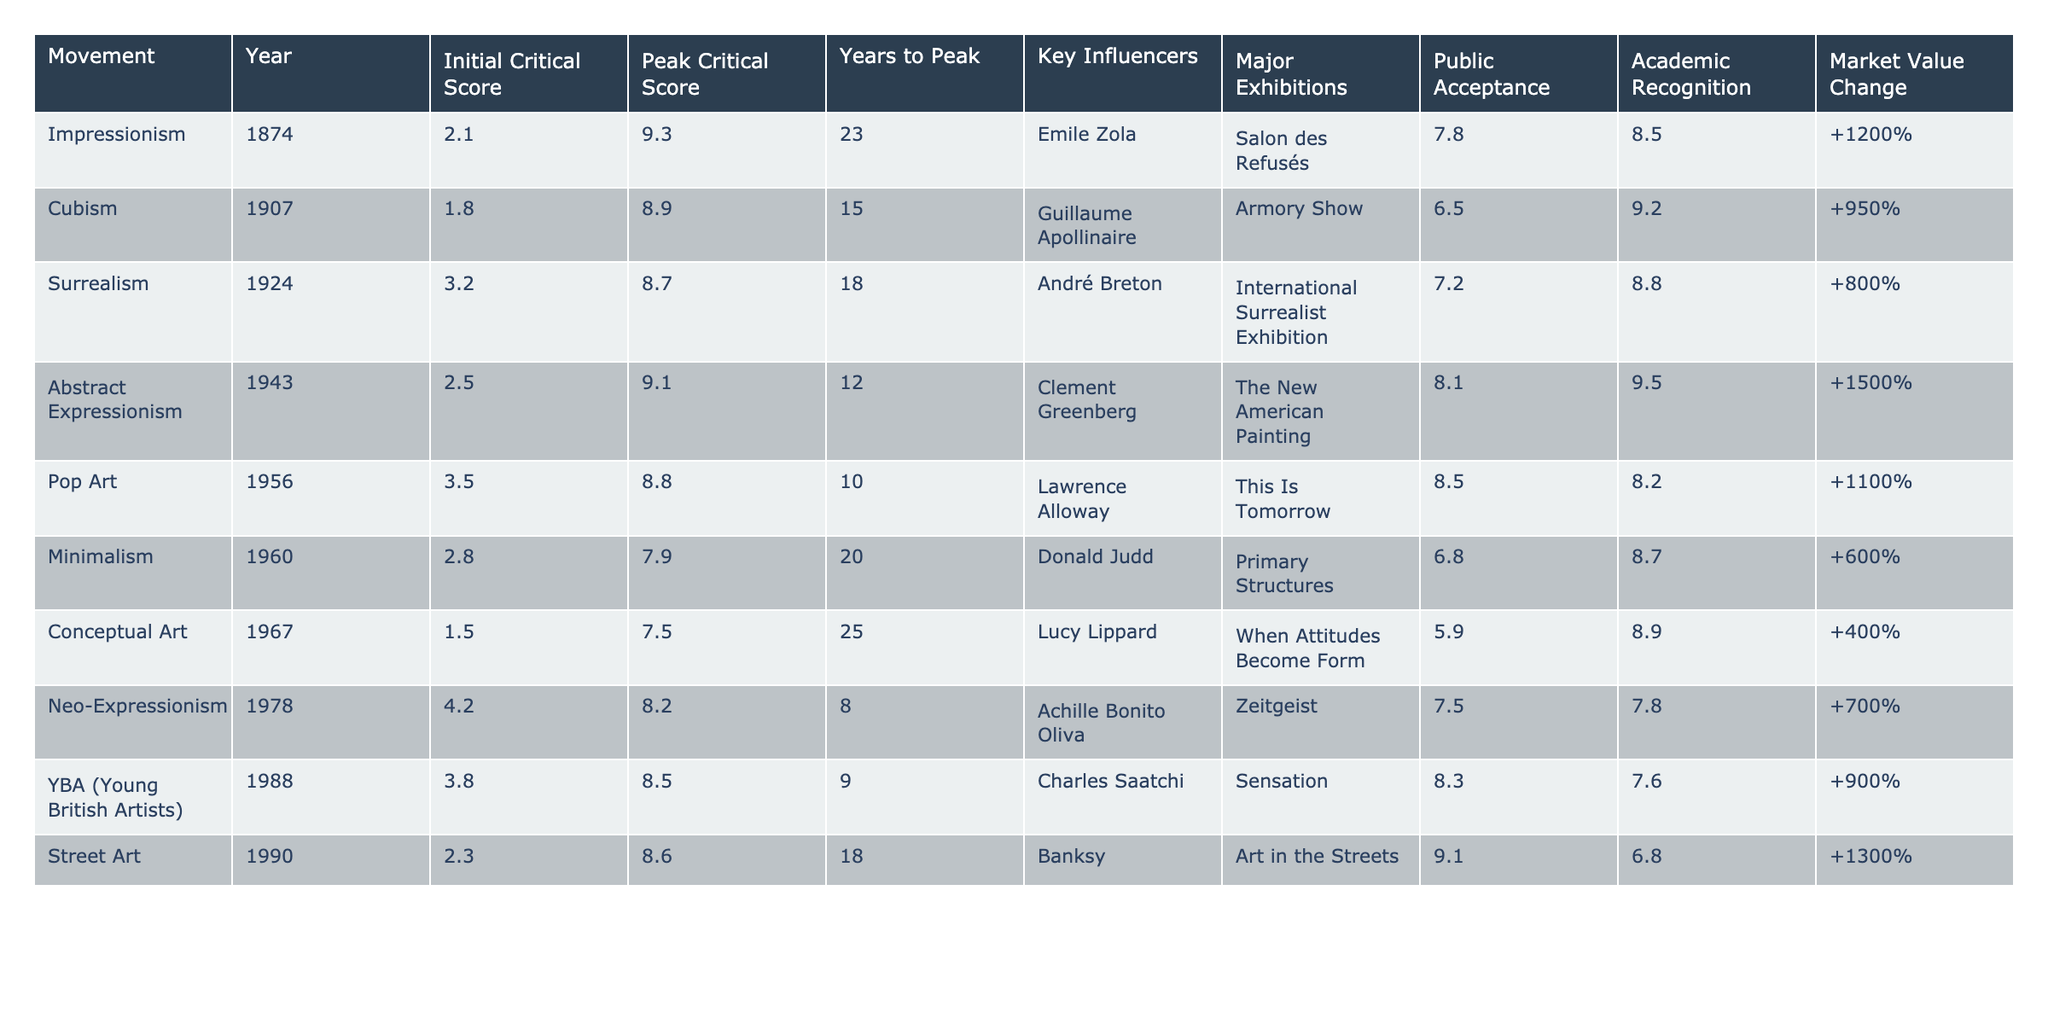What was the peak critical score for Abstract Expressionism? According to the table, the peak critical score for Abstract Expressionism is listed as 9.1.
Answer: 9.1 Which art movement had the highest initial critical score? By examining the initial critical scores in the table, Abstract Expressionism has the highest initial score of 2.5 compared to other movements.
Answer: Abstract Expressionism How many years did it take for Cubism to reach its peak critical score? The table shows that Cubism took 15 years to reach its peak critical score, as indicated under the "Years to Peak" column.
Answer: 15 years Is it true that Minimalism had a higher peak critical score than Surrealism? The peak critical score for Minimalism is 7.9, while Surrealism's peak score is 8.7, making the statement false.
Answer: No What is the difference in public acceptance between Pop Art and Street Art? The public acceptance for Pop Art is 8.5 and for Street Art is 9.1. The difference is calculated as 9.1 - 8.5 = 0.6.
Answer: 0.6 For which movement was the major exhibition 'Sensation' held? Looking at the table, the major exhibition 'Sensation' is associated with YBA (Young British Artists) in 1988.
Answer: YBA (Young British Artists) What is the average market value change for the first three movements listed? The market value changes for the first three movements (Impressionism, Cubism, and Surrealism) are +1200%, +950%, and +800%, respectively. Summing these values: 1200 + 950 + 800 = 2950, and dividing by 3 gives an average of 2950/3 = 983.33.
Answer: 983.33% Which movement had the lowest public acceptance score? By scanning the table, Conceptual Art has the lowest public acceptance score of 5.9 among the movements listed.
Answer: Conceptual Art If you list the movements in order of peak critical score, which one is in fifth place? The peak critical scores in descending order place Surrealism (8.7) fifth after Abstract Expressionism (9.1), Pop Art (8.8), and Cubism (8.9).
Answer: Surrealism How does the average years to peak compare between movements with critical scores over 8? The following movements have peak critical scores over 8: Impressionism (23 years), Cubism (15 years), Abstract Expressionism (12 years), Pop Art (10 years), and Street Art (18 years). The average is calculated as (23 + 15 + 12 + 10 + 18) / 5 = 15.6 years.
Answer: 15.6 years 